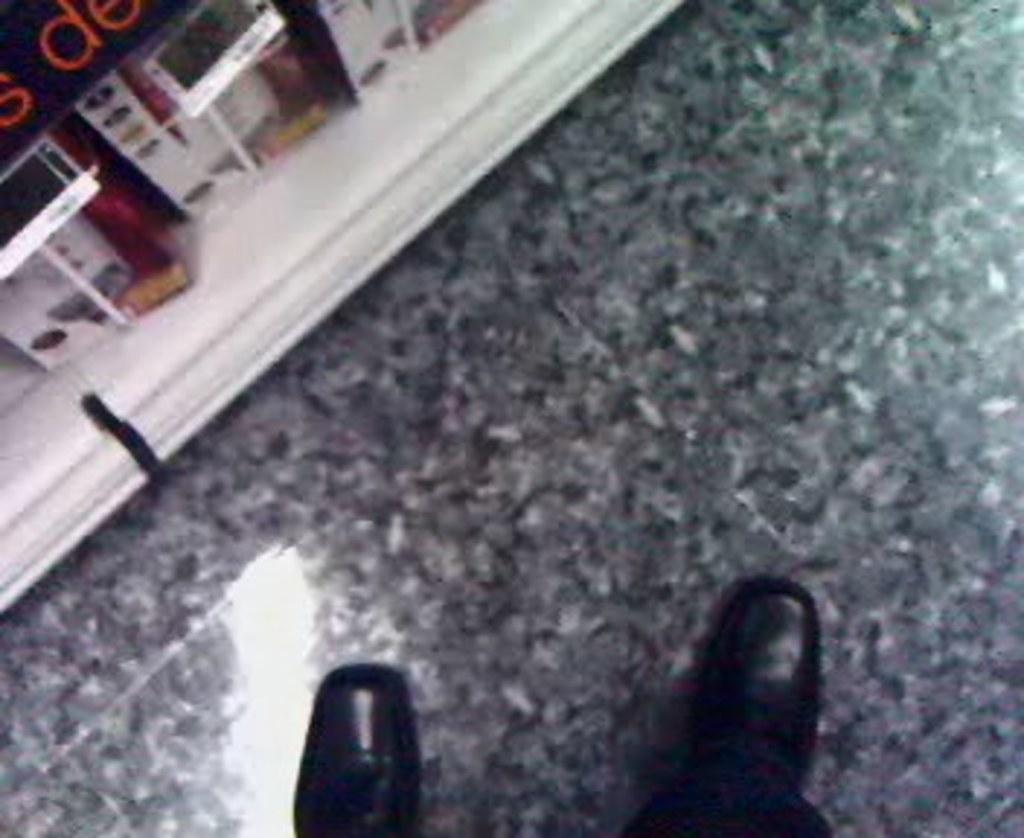Please provide a concise description of this image. In this image, we can see the legs of a person wearing shoes and standing on the floor. 